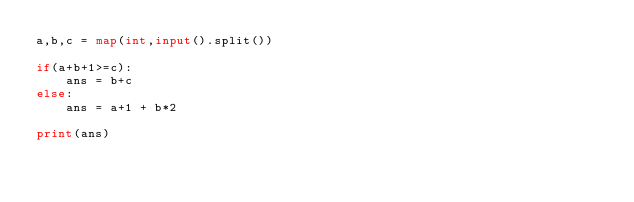Convert code to text. <code><loc_0><loc_0><loc_500><loc_500><_Python_>a,b,c = map(int,input().split())

if(a+b+1>=c):
    ans = b+c
else:
    ans = a+1 + b*2

print(ans)</code> 